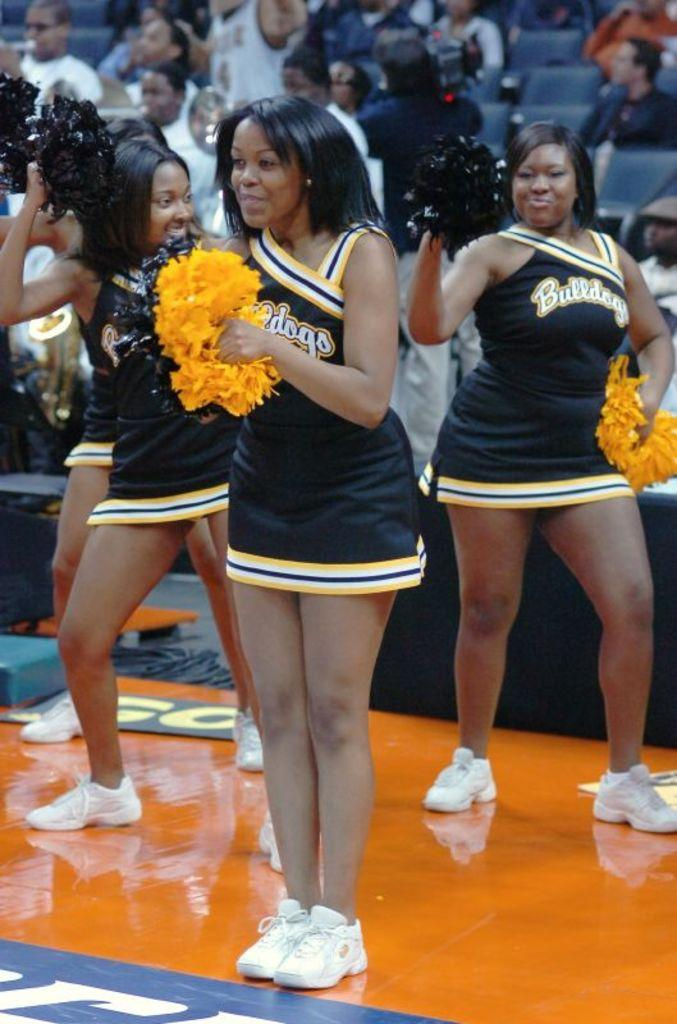<image>
Provide a brief description of the given image. Cheerleaders are wearing black and gold uniforms that say Bulldogs. 